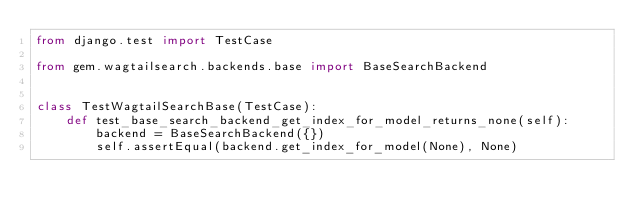<code> <loc_0><loc_0><loc_500><loc_500><_Python_>from django.test import TestCase

from gem.wagtailsearch.backends.base import BaseSearchBackend


class TestWagtailSearchBase(TestCase):
    def test_base_search_backend_get_index_for_model_returns_none(self):
        backend = BaseSearchBackend({})
        self.assertEqual(backend.get_index_for_model(None), None)
</code> 